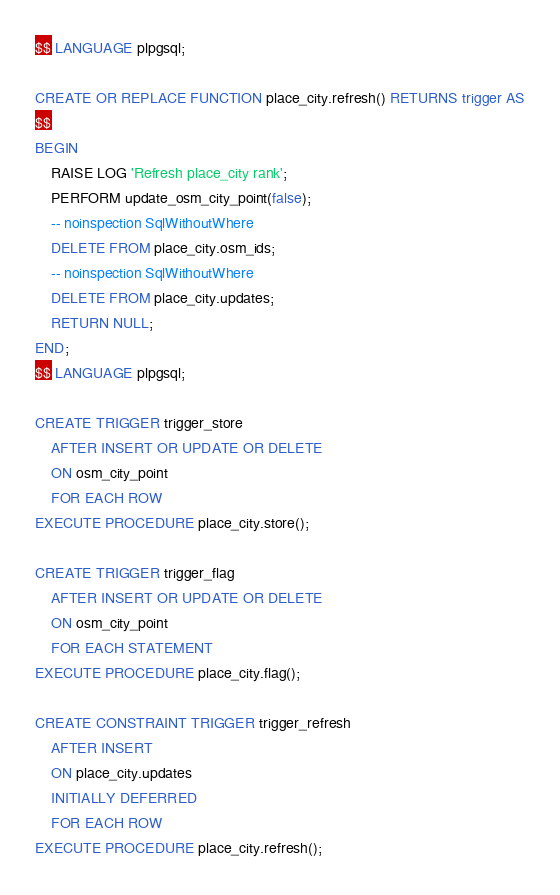<code> <loc_0><loc_0><loc_500><loc_500><_SQL_>$$ LANGUAGE plpgsql;

CREATE OR REPLACE FUNCTION place_city.refresh() RETURNS trigger AS
$$
BEGIN
    RAISE LOG 'Refresh place_city rank';
    PERFORM update_osm_city_point(false);
    -- noinspection SqlWithoutWhere
    DELETE FROM place_city.osm_ids;
    -- noinspection SqlWithoutWhere
    DELETE FROM place_city.updates;
    RETURN NULL;
END;
$$ LANGUAGE plpgsql;

CREATE TRIGGER trigger_store
    AFTER INSERT OR UPDATE OR DELETE
    ON osm_city_point
    FOR EACH ROW
EXECUTE PROCEDURE place_city.store();

CREATE TRIGGER trigger_flag
    AFTER INSERT OR UPDATE OR DELETE
    ON osm_city_point
    FOR EACH STATEMENT
EXECUTE PROCEDURE place_city.flag();

CREATE CONSTRAINT TRIGGER trigger_refresh
    AFTER INSERT
    ON place_city.updates
    INITIALLY DEFERRED
    FOR EACH ROW
EXECUTE PROCEDURE place_city.refresh();
</code> 